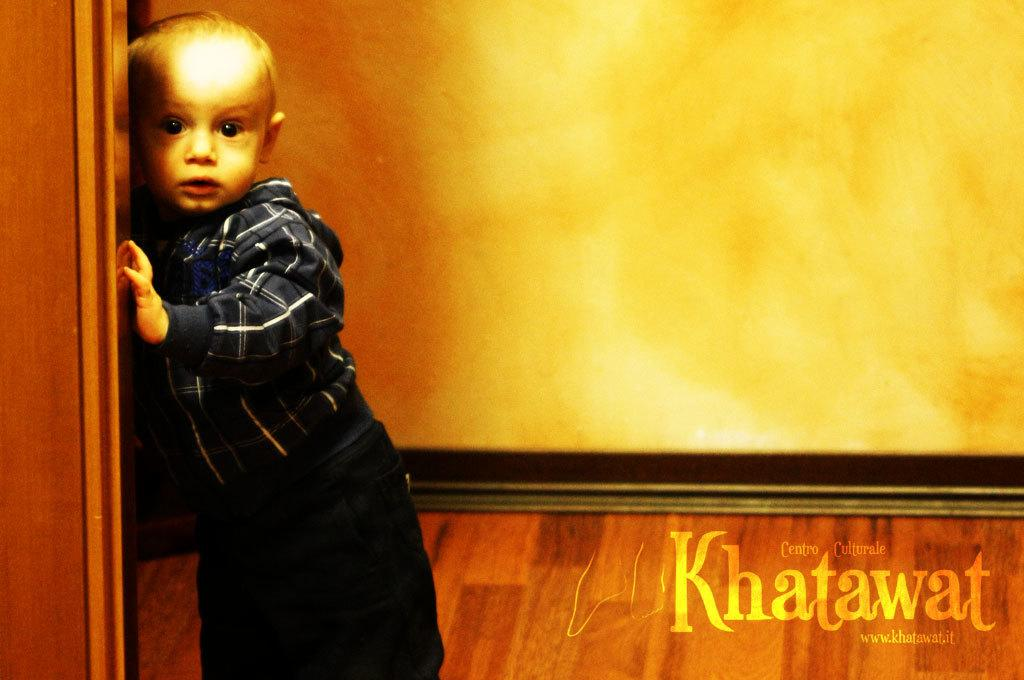What is the kid holding on the left side of the image? The kid is holding a wooden object on the left side of the image. What can be seen on the right side of the image? There is text on the right side of the image. What is the main structure in the center of the image? There is a well in the center of the image. What type of discovery was made near the well in the image? There is no indication of a discovery in the image; it only shows a kid holding a wooden object, text on the right side, and a well in the center. What type of pump is used to draw water from the well in the image? There is no pump visible in the image; it only shows a well in the center. 